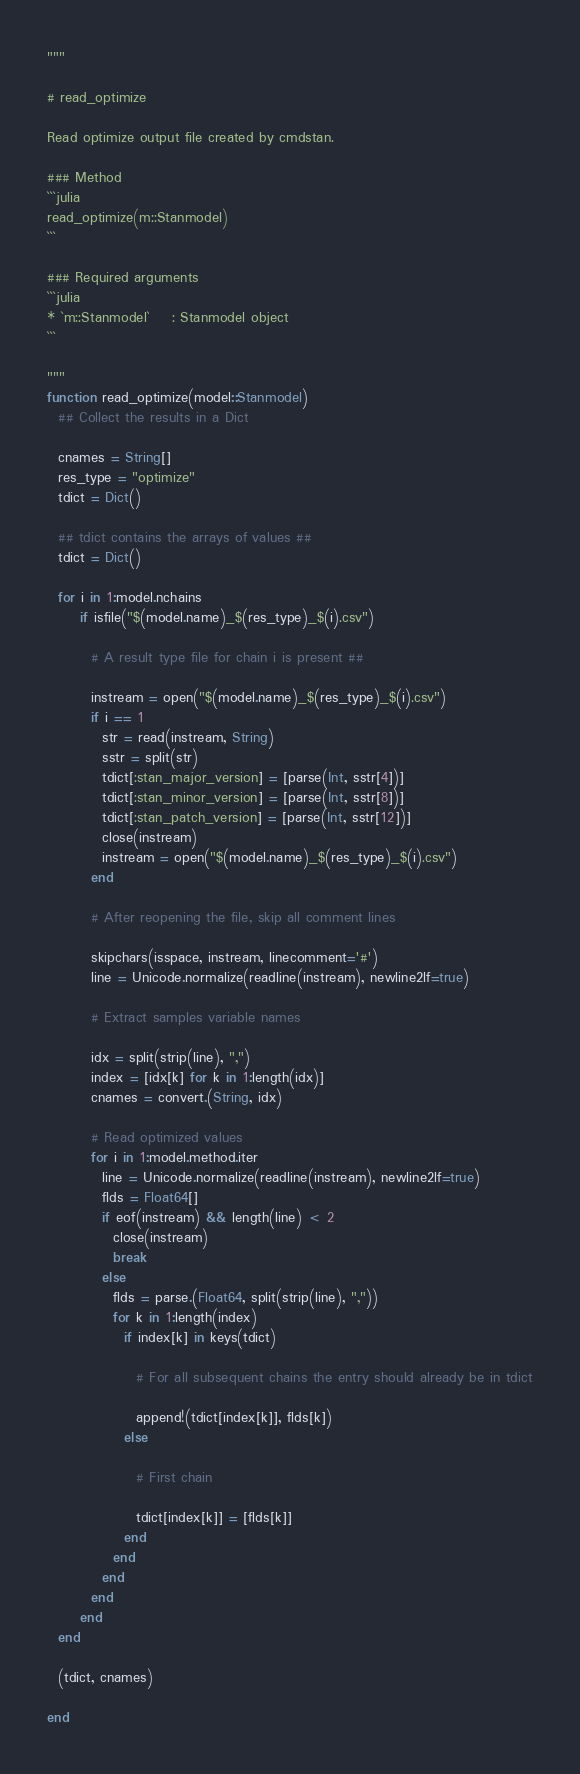Convert code to text. <code><loc_0><loc_0><loc_500><loc_500><_Julia_>"""

# read_optimize

Read optimize output file created by cmdstan. 

### Method
```julia
read_optimize(m::Stanmodel)
```

### Required arguments
```julia
* `m::Stanmodel`    : Stanmodel object
```

"""
function read_optimize(model::Stanmodel)
  ## Collect the results in a Dict
  
  cnames = String[]
  res_type = "optimize"
  tdict = Dict()
  
  ## tdict contains the arrays of values ##
  tdict = Dict()
  
  for i in 1:model.nchains
      if isfile("$(model.name)_$(res_type)_$(i).csv")
        
        # A result type file for chain i is present ##
        
        instream = open("$(model.name)_$(res_type)_$(i).csv")
        if i == 1
          str = read(instream, String)
          sstr = split(str)
          tdict[:stan_major_version] = [parse(Int, sstr[4])]
          tdict[:stan_minor_version] = [parse(Int, sstr[8])]
          tdict[:stan_patch_version] = [parse(Int, sstr[12])]
          close(instream)
          instream = open("$(model.name)_$(res_type)_$(i).csv")
        end
        
        # After reopening the file, skip all comment lines
        
        skipchars(isspace, instream, linecomment='#')
        line = Unicode.normalize(readline(instream), newline2lf=true)
        
        # Extract samples variable names
        
        idx = split(strip(line), ",")
        index = [idx[k] for k in 1:length(idx)]
        cnames = convert.(String, idx)

        # Read optimized values
        for i in 1:model.method.iter
          line = Unicode.normalize(readline(instream), newline2lf=true)
          flds = Float64[]
          if eof(instream) && length(line) < 2
            close(instream)
            break
          else
            flds = parse.(Float64, split(strip(line), ","))
            for k in 1:length(index)
              if index[k] in keys(tdict)
                
                # For all subsequent chains the entry should already be in tdict
                
                append!(tdict[index[k]], flds[k])
              else
                
                # First chain
                
                tdict[index[k]] = [flds[k]]
              end
            end
          end
        end
      end
  end
  
  (tdict, cnames)
  
end

</code> 